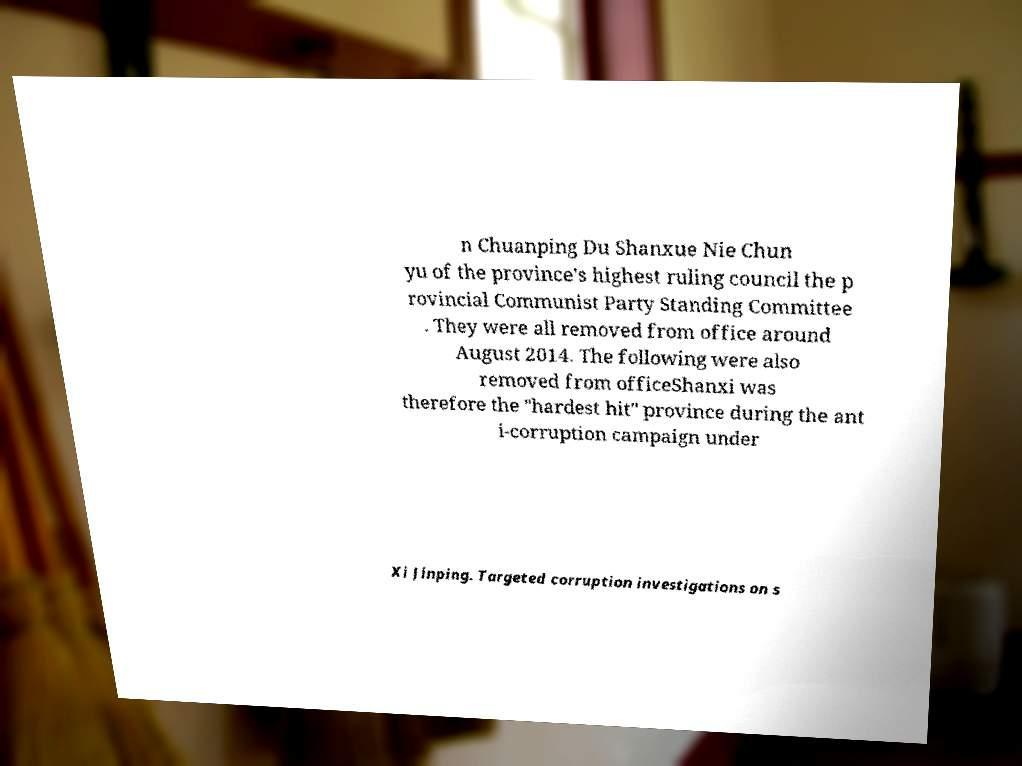For documentation purposes, I need the text within this image transcribed. Could you provide that? n Chuanping Du Shanxue Nie Chun yu of the province's highest ruling council the p rovincial Communist Party Standing Committee . They were all removed from office around August 2014. The following were also removed from officeShanxi was therefore the "hardest hit" province during the ant i-corruption campaign under Xi Jinping. Targeted corruption investigations on s 